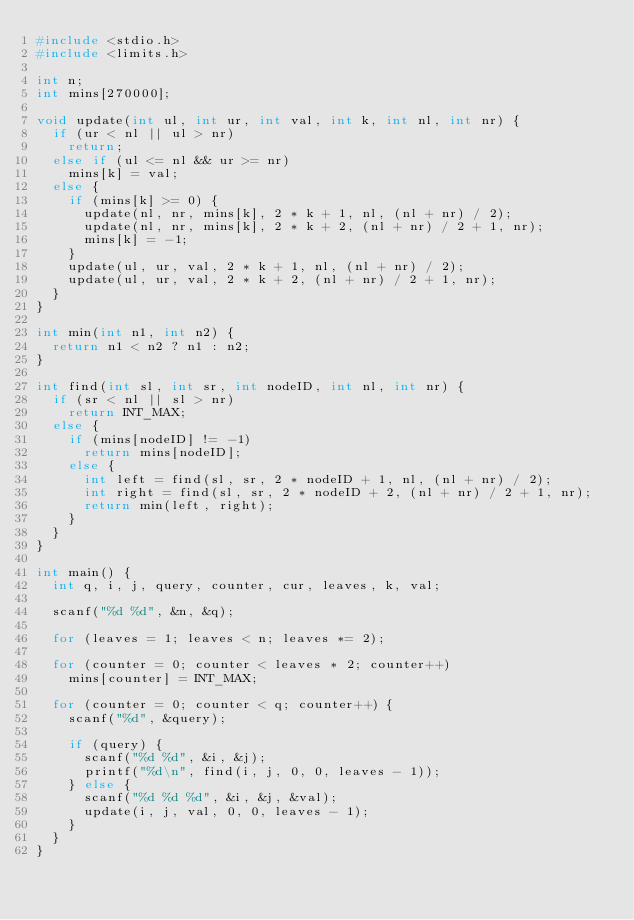Convert code to text. <code><loc_0><loc_0><loc_500><loc_500><_C_>#include <stdio.h>
#include <limits.h>

int n;
int mins[270000];

void update(int ul, int ur, int val, int k, int nl, int nr) {
  if (ur < nl || ul > nr)
    return;
  else if (ul <= nl && ur >= nr)
    mins[k] = val;
  else {
    if (mins[k] >= 0) {
      update(nl, nr, mins[k], 2 * k + 1, nl, (nl + nr) / 2);
      update(nl, nr, mins[k], 2 * k + 2, (nl + nr) / 2 + 1, nr);
      mins[k] = -1;
    }
    update(ul, ur, val, 2 * k + 1, nl, (nl + nr) / 2);
    update(ul, ur, val, 2 * k + 2, (nl + nr) / 2 + 1, nr);
  }
}

int min(int n1, int n2) {
  return n1 < n2 ? n1 : n2;
}

int find(int sl, int sr, int nodeID, int nl, int nr) {
  if (sr < nl || sl > nr)
    return INT_MAX;
  else {
    if (mins[nodeID] != -1)
      return mins[nodeID];
    else {
      int left = find(sl, sr, 2 * nodeID + 1, nl, (nl + nr) / 2);
      int right = find(sl, sr, 2 * nodeID + 2, (nl + nr) / 2 + 1, nr);
      return min(left, right);
    }
  }
}

int main() {
  int q, i, j, query, counter, cur, leaves, k, val;

  scanf("%d %d", &n, &q);

  for (leaves = 1; leaves < n; leaves *= 2);

  for (counter = 0; counter < leaves * 2; counter++)
    mins[counter] = INT_MAX;

  for (counter = 0; counter < q; counter++) {
    scanf("%d", &query);

    if (query) {
      scanf("%d %d", &i, &j);
      printf("%d\n", find(i, j, 0, 0, leaves - 1));
    } else {
      scanf("%d %d %d", &i, &j, &val);
      update(i, j, val, 0, 0, leaves - 1);
    }
  }
}

</code> 